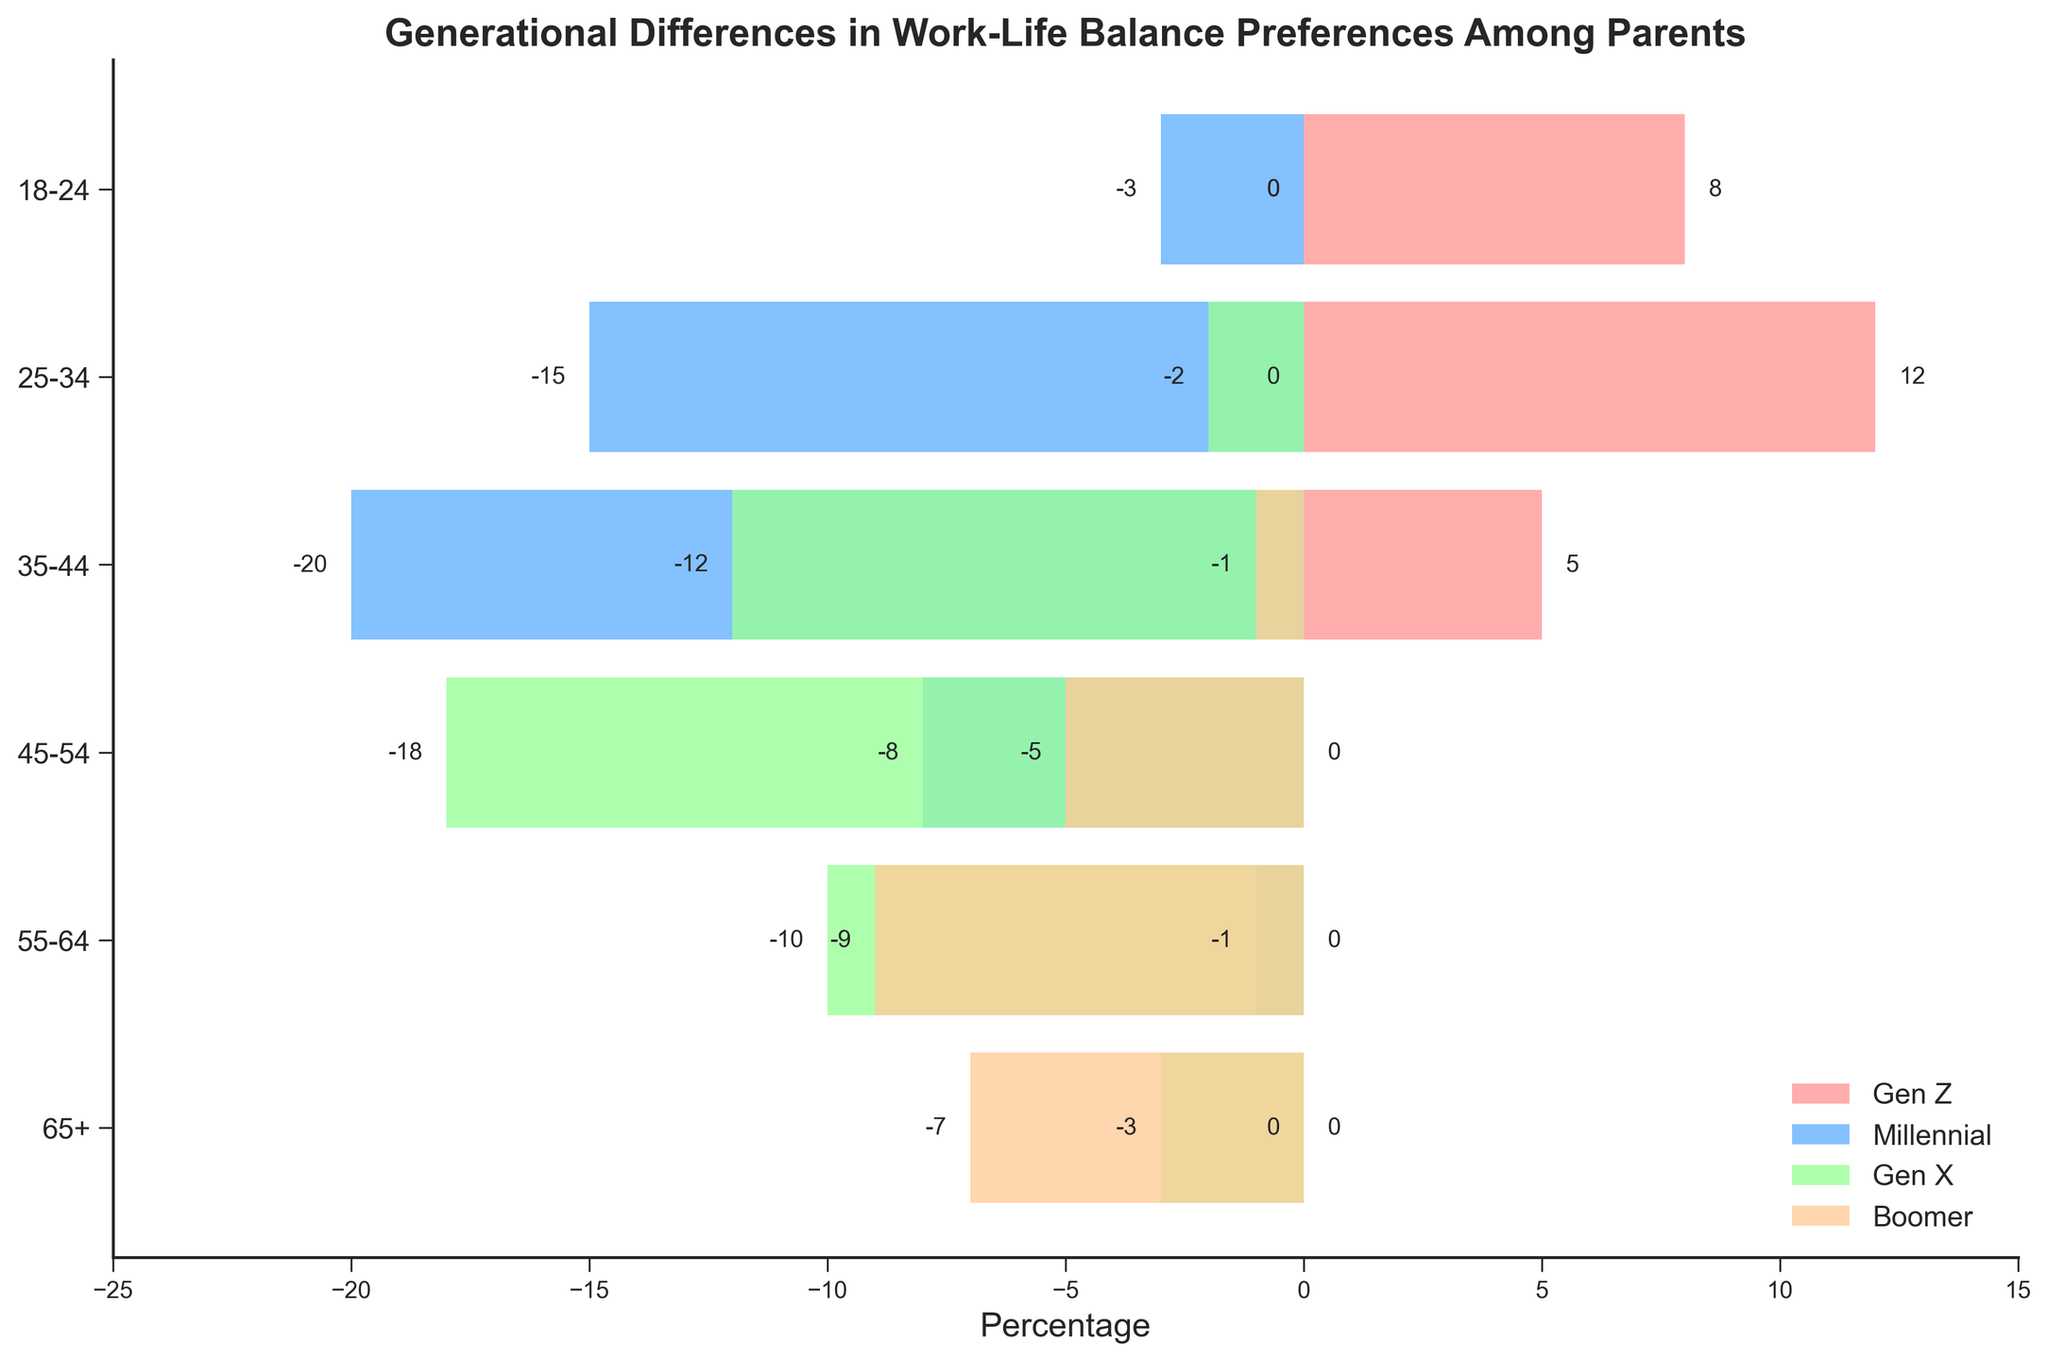What is the percentage of Gen Z parents in the 25-34 age group? The figure shows a bar for Gen Z parents in the 25-34 age group extending to 12.
Answer: 12 What is the largest negative percentage value shown for Millennial parents? Among the negative values for Millennial parents, the largest (most negative) one is -20 in the 35-44 age group.
Answer: -20 How many age groups have zero percentages for Boomer parents? The bars representing Boomer parents have zero percentages for the 18-24 and 25-34 age groups.
Answer: 2 Which generation has the highest percentage in the 35-44 age group? The bars for the 35-44 age group show Gen Z with 5, Millennial with -20, Gen X with -12, and Boomer with -1. The highest value among these is 5 for Gen Z.
Answer: Gen Z In which age group do Gen X parents have a greater negative percentage than Millennial parents? For the age group 45-54, Gen X parents have -18 and Millennial parents have -8. Here, -18 is more negative than -8.
Answer: 45-54 Compare the percentages of Gen Z and Boomer parents in the 25-34 age group. Which is higher? In the 25-34 age group, Gen Z parents have a percentage of 12 and Boomer parents have a percentage of 0. Thus, the percentage for Gen Z parents is higher.
Answer: Gen Z Which generation has no preference data in the 18-24 age group? The bars for Gen X and Boomer parents in the 18-24 age group are at 0, indicating no preference data.
Answer: Gen X and Boomer Calculate the sum of the percentages of Millennial parents in the 35-44 and 45-54 age groups. In the 35-44 age group, Millennial parents have -20, and in the 45-54 age group, they have -8. The sum is -20 + (-8) = -28.
Answer: -28 